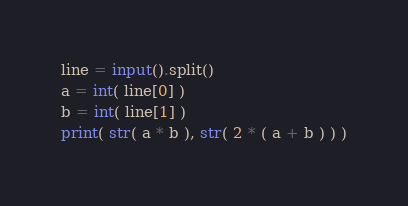<code> <loc_0><loc_0><loc_500><loc_500><_Python_>line = input().split()
a = int( line[0] )
b = int( line[1] )
print( str( a * b ), str( 2 * ( a + b ) ) )

</code> 